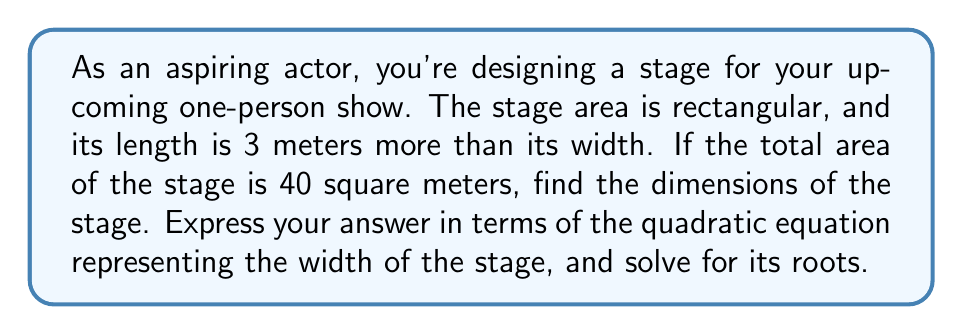Give your solution to this math problem. Let's approach this step-by-step:

1) Let $x$ represent the width of the stage in meters.
2) The length is 3 meters more than the width, so it's represented by $(x+3)$.
3) The area of a rectangle is given by length × width. So we can write:
   $x(x+3) = 40$

4) Expand the equation:
   $x^2 + 3x = 40$

5) Rearrange to standard form $(ax^2 + bx + c = 0)$:
   $x^2 + 3x - 40 = 0$

6) This is our quadratic equation. To find its roots, we can use the quadratic formula:
   $x = \frac{-b \pm \sqrt{b^2 - 4ac}}{2a}$

   Where $a=1$, $b=3$, and $c=-40$

7) Substituting these values:
   $x = \frac{-3 \pm \sqrt{3^2 - 4(1)(-40)}}{2(1)}$

8) Simplify under the square root:
   $x = \frac{-3 \pm \sqrt{9 + 160}}{2} = \frac{-3 \pm \sqrt{169}}{2} = \frac{-3 \pm 13}{2}$

9) This gives us two solutions:
   $x = \frac{-3 + 13}{2} = 5$ or $x = \frac{-3 - 13}{2} = -8$

10) Since width cannot be negative, we discard the negative solution.

Therefore, the width of the stage is 5 meters, and the length is 8 meters (5 + 3).
Answer: Roots: $x = 5$ or $x = -8$; Stage dimensions: 5m × 8m 